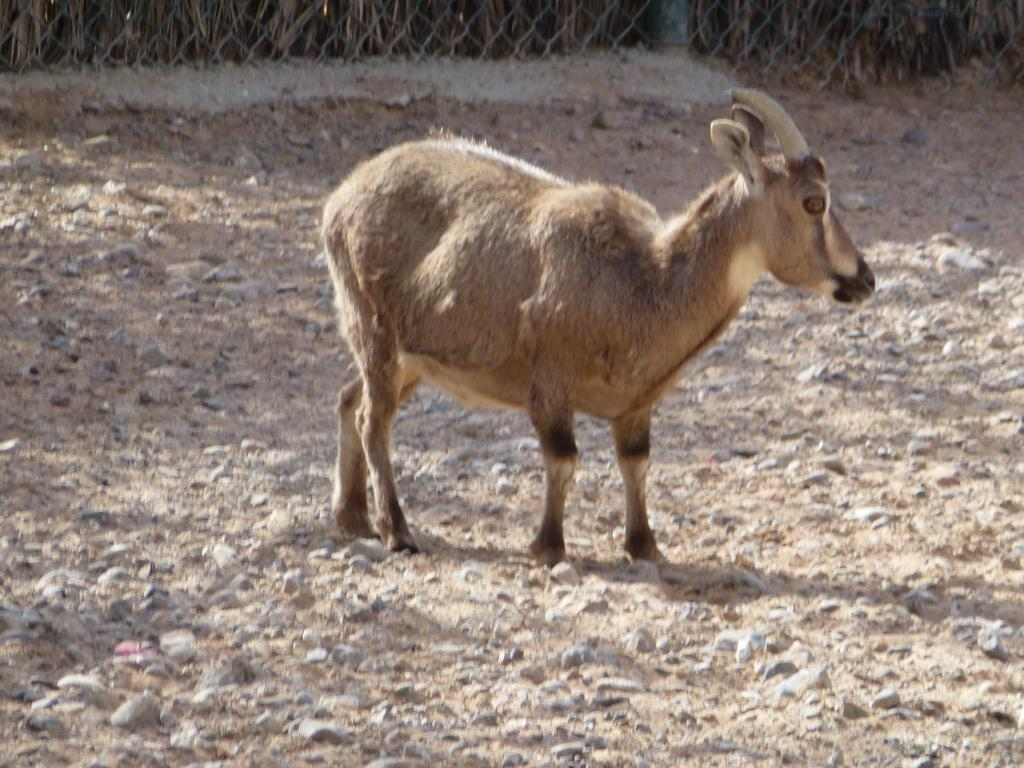What type of creature is in the image? There is an animal in the image. Where is the animal located in relation to the image? The animal is in the front of the image. What can be seen in the background of the image? There is a fence in the background of the image. What type of plant is the animal wearing as a suit in the image? There is no plant or suit present in the image; it features an animal in the front with a fence in the background. 